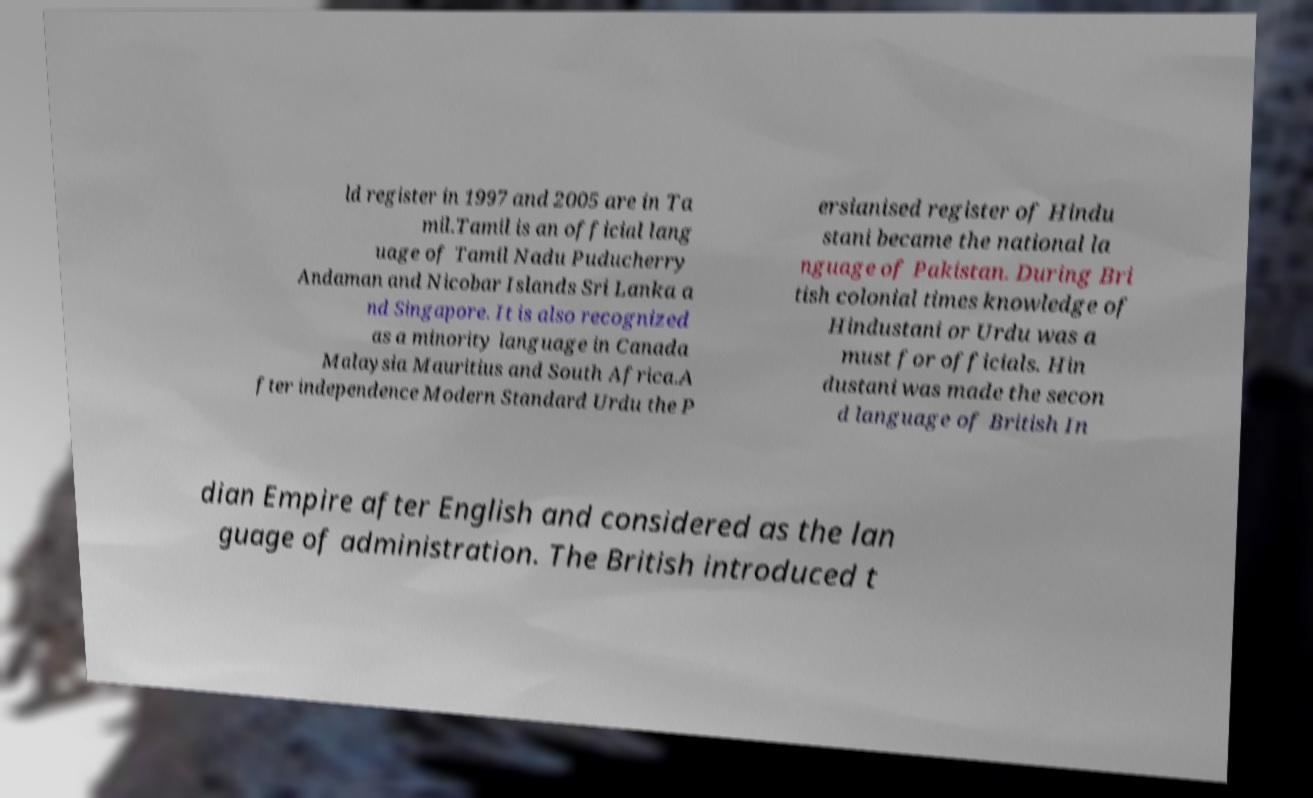Could you extract and type out the text from this image? ld register in 1997 and 2005 are in Ta mil.Tamil is an official lang uage of Tamil Nadu Puducherry Andaman and Nicobar Islands Sri Lanka a nd Singapore. It is also recognized as a minority language in Canada Malaysia Mauritius and South Africa.A fter independence Modern Standard Urdu the P ersianised register of Hindu stani became the national la nguage of Pakistan. During Bri tish colonial times knowledge of Hindustani or Urdu was a must for officials. Hin dustani was made the secon d language of British In dian Empire after English and considered as the lan guage of administration. The British introduced t 